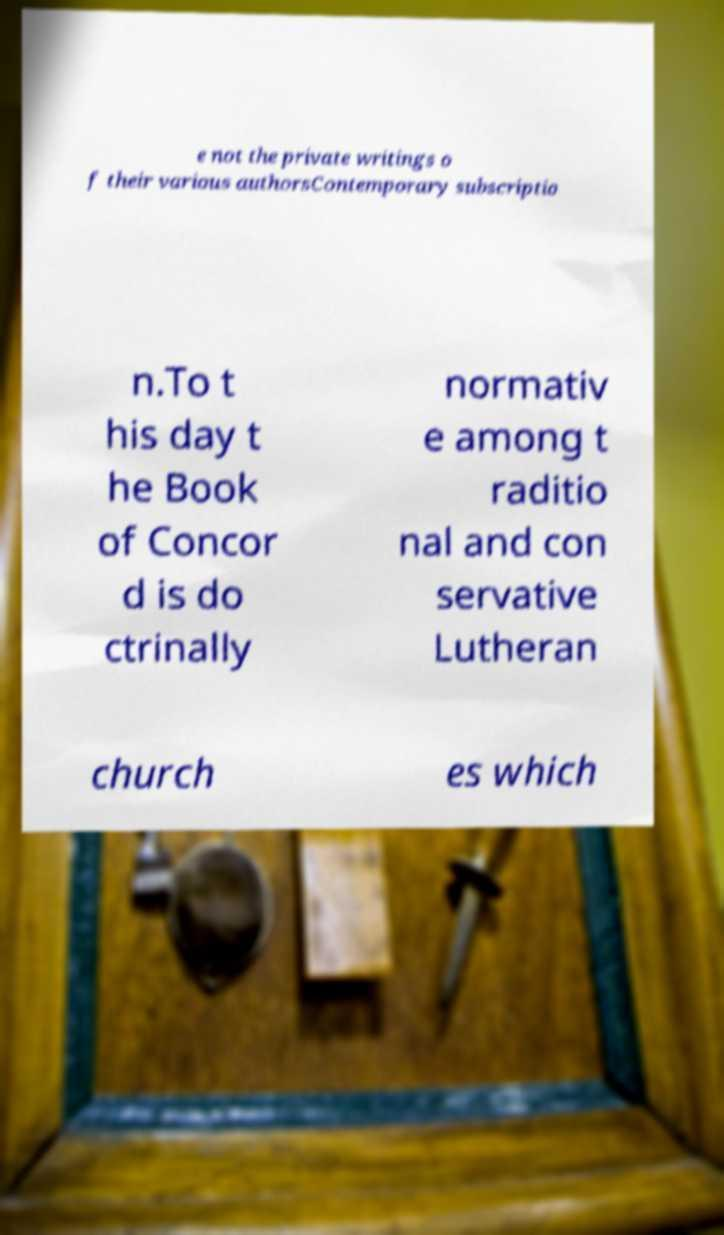Could you assist in decoding the text presented in this image and type it out clearly? e not the private writings o f their various authorsContemporary subscriptio n.To t his day t he Book of Concor d is do ctrinally normativ e among t raditio nal and con servative Lutheran church es which 